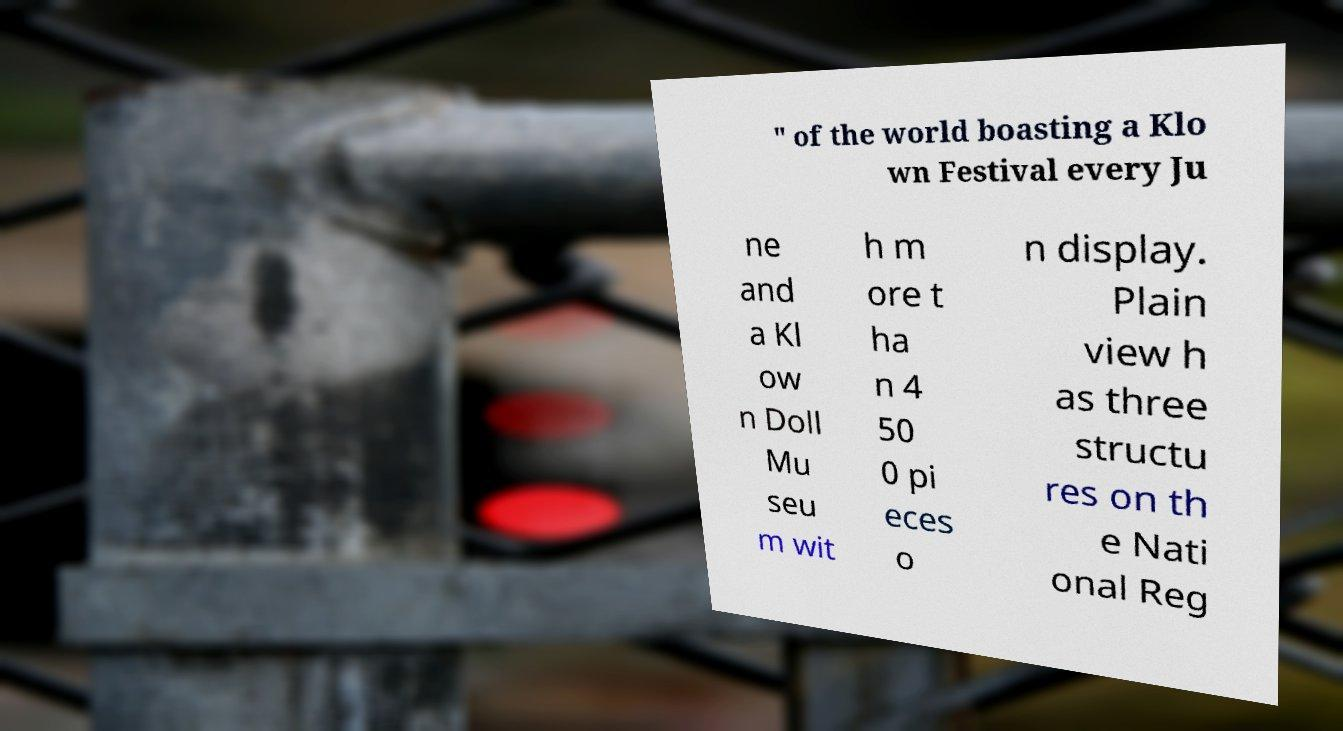What messages or text are displayed in this image? I need them in a readable, typed format. " of the world boasting a Klo wn Festival every Ju ne and a Kl ow n Doll Mu seu m wit h m ore t ha n 4 50 0 pi eces o n display. Plain view h as three structu res on th e Nati onal Reg 